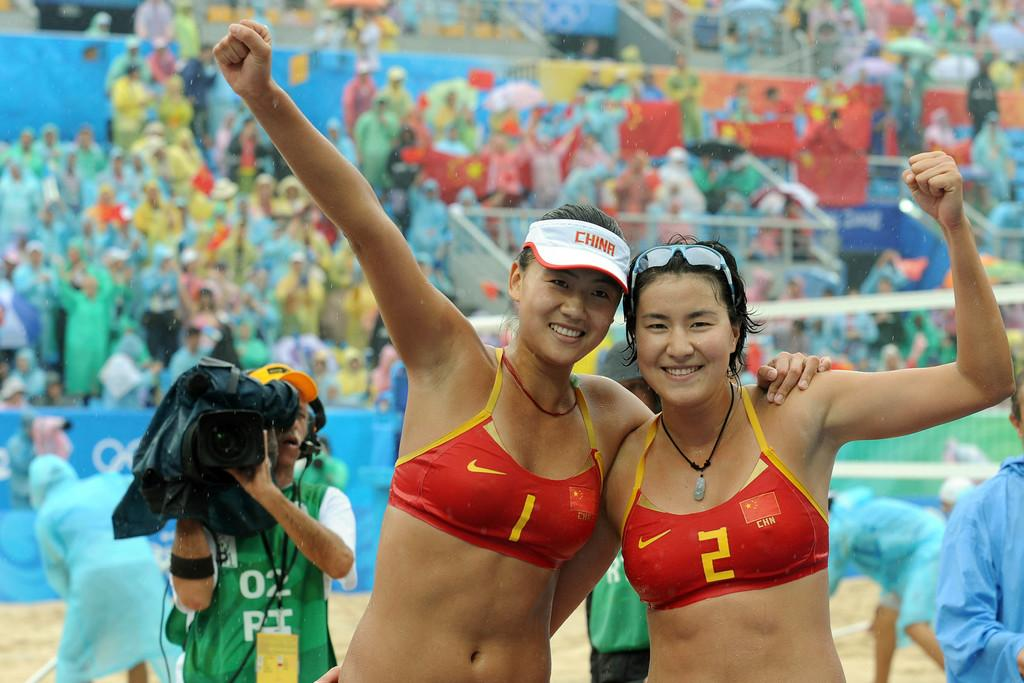<image>
Give a short and clear explanation of the subsequent image. Two young women in bikinis numbered 1 and 2 hug and celebrate together. 